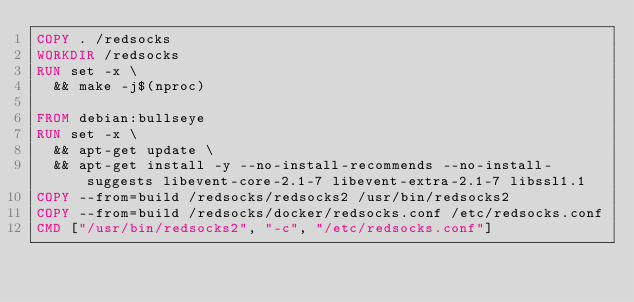<code> <loc_0><loc_0><loc_500><loc_500><_Dockerfile_>COPY . /redsocks
WORKDIR /redsocks
RUN set -x \
	&& make -j$(nproc)

FROM debian:bullseye
RUN set -x \
	&& apt-get update \
	&& apt-get install -y --no-install-recommends --no-install-suggests libevent-core-2.1-7 libevent-extra-2.1-7 libssl1.1
COPY --from=build /redsocks/redsocks2 /usr/bin/redsocks2
COPY --from=build /redsocks/docker/redsocks.conf /etc/redsocks.conf
CMD ["/usr/bin/redsocks2", "-c", "/etc/redsocks.conf"]
</code> 